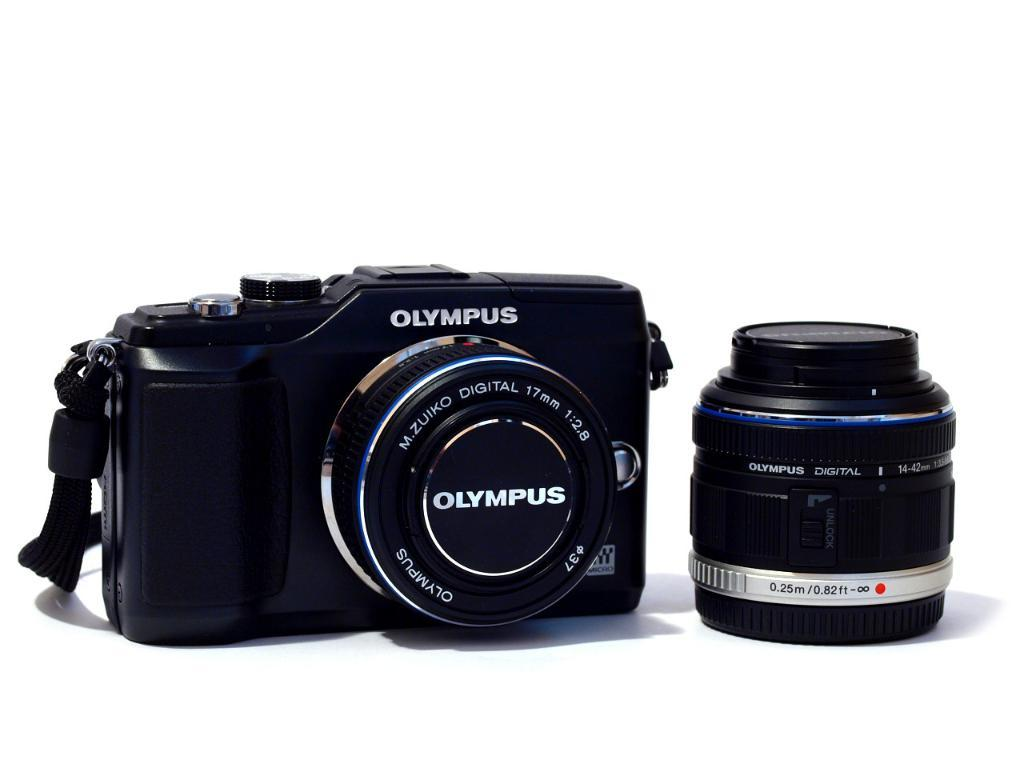Provide a one-sentence caption for the provided image. A black Olympus digital camera and zoom lens. 